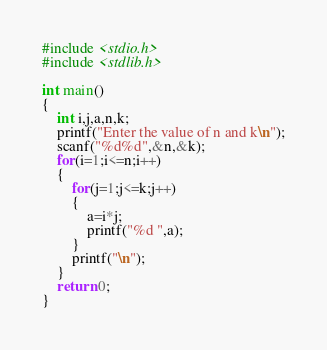Convert code to text. <code><loc_0><loc_0><loc_500><loc_500><_C_>#include <stdio.h>
#include <stdlib.h>

int main()
{
    int i,j,a,n,k;
    printf("Enter the value of n and k\n");
    scanf("%d%d",&n,&k);
    for(i=1;i<=n;i++)
    {
        for(j=1;j<=k;j++)
        {
            a=i*j;
            printf("%d ",a);
        }
        printf("\n");
    }
    return 0;
}
</code> 